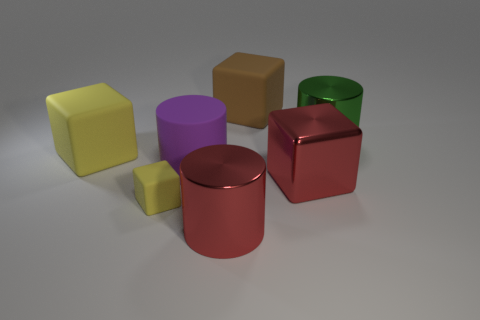Subtract 1 cubes. How many cubes are left? 3 Add 2 green shiny cylinders. How many objects exist? 9 Subtract all cylinders. How many objects are left? 4 Subtract all big matte cubes. Subtract all big purple matte objects. How many objects are left? 4 Add 3 big purple matte things. How many big purple matte things are left? 4 Add 4 big green things. How many big green things exist? 5 Subtract 1 red cylinders. How many objects are left? 6 